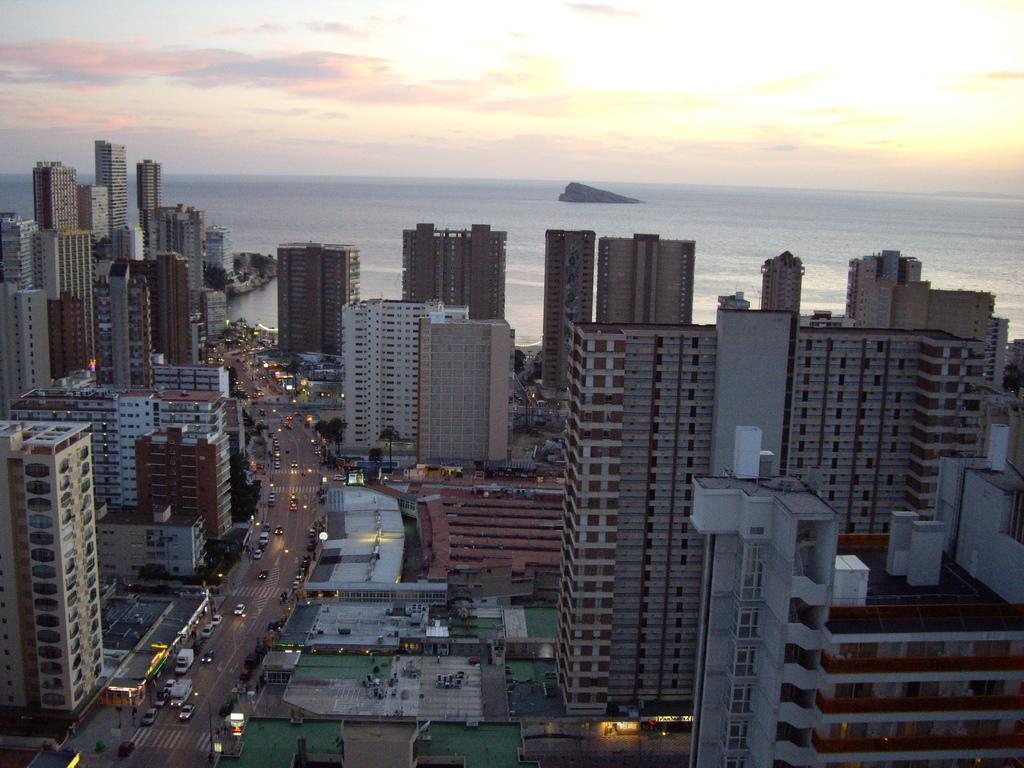Can you describe this image briefly? In the center of the image there are many buildings and there is a road,where there are many vehicles passing on it. At the background of the image there is water. At the top the image there is a sky. 